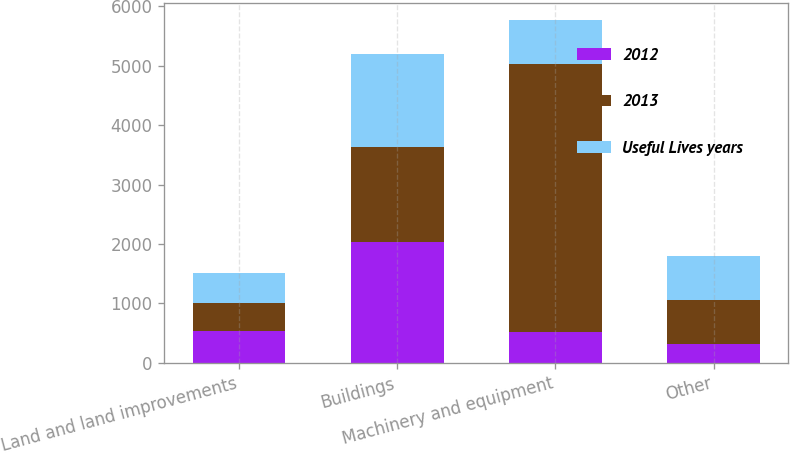Convert chart to OTSL. <chart><loc_0><loc_0><loc_500><loc_500><stacked_bar_chart><ecel><fcel>Land and land improvements<fcel>Buildings<fcel>Machinery and equipment<fcel>Other<nl><fcel>2012<fcel>530<fcel>2040<fcel>525<fcel>320<nl><fcel>2013<fcel>473<fcel>1593<fcel>4513<fcel>743<nl><fcel>Useful Lives years<fcel>504<fcel>1568<fcel>735<fcel>735<nl></chart> 